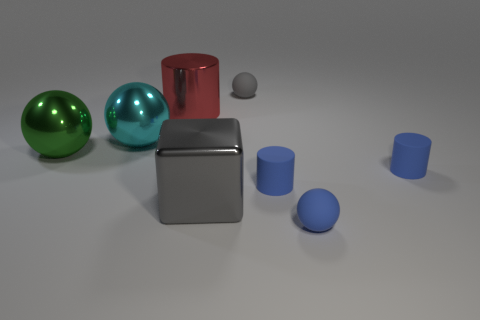Is the big cyan thing made of the same material as the block?
Ensure brevity in your answer.  Yes. What color is the sphere that is on the right side of the red shiny cylinder and in front of the red object?
Provide a succinct answer. Blue. Is there a green shiny sphere that has the same size as the gray shiny object?
Your response must be concise. Yes. How big is the rubber cylinder that is left of the ball that is in front of the gray metal object?
Make the answer very short. Small. Are there fewer large cylinders to the left of the large cyan metallic thing than tiny gray spheres?
Offer a terse response. Yes. Do the cube and the large cylinder have the same color?
Keep it short and to the point. No. How big is the gray metal thing?
Your answer should be very brief. Large. How many big balls have the same color as the big metal cube?
Give a very brief answer. 0. There is a small blue object that is on the left side of the rubber sphere to the right of the gray rubber thing; are there any gray objects that are behind it?
Make the answer very short. Yes. What shape is the cyan shiny object that is the same size as the block?
Offer a terse response. Sphere. 